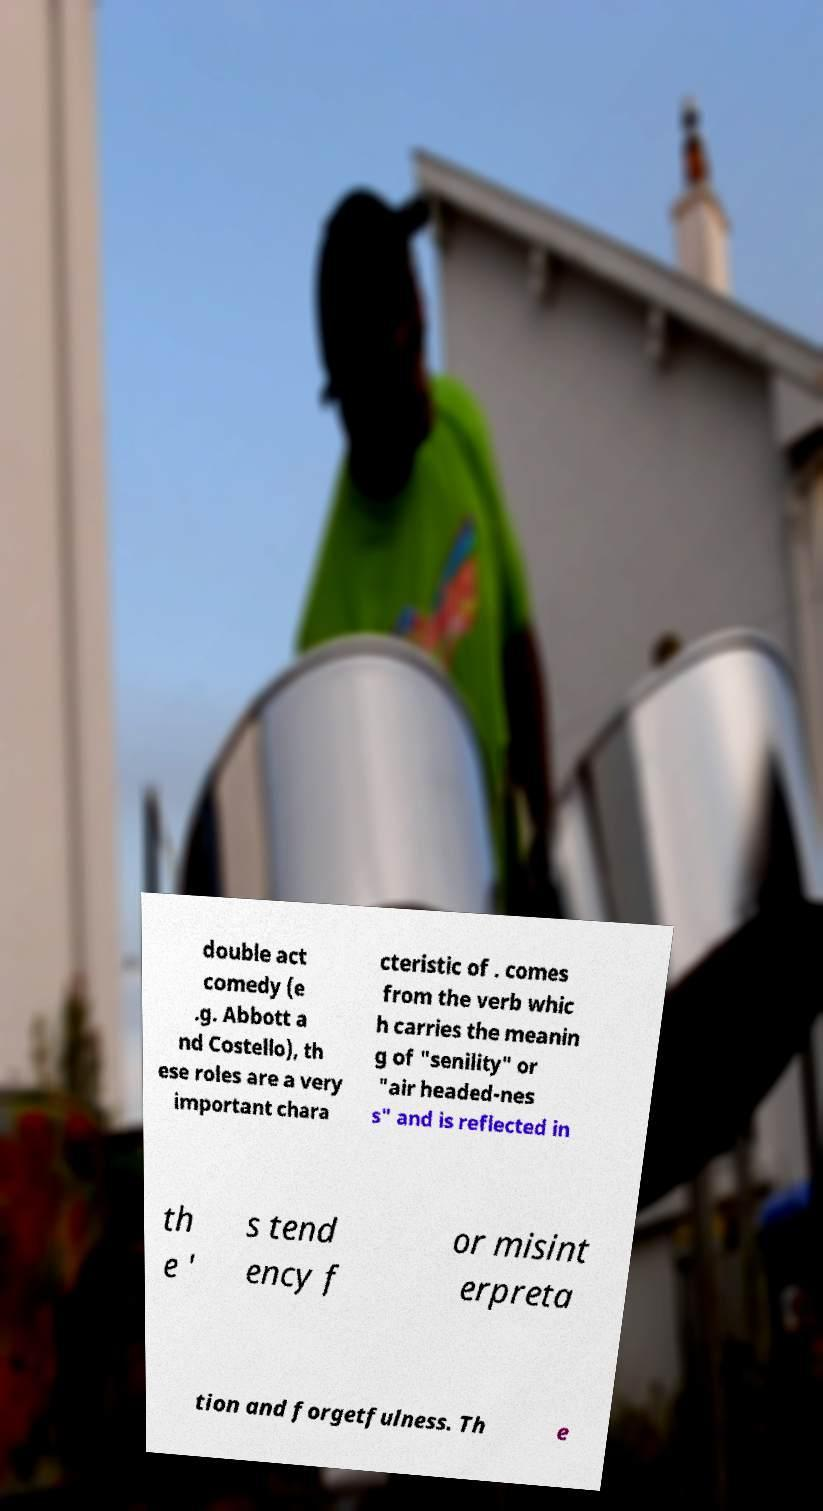Please read and relay the text visible in this image. What does it say? double act comedy (e .g. Abbott a nd Costello), th ese roles are a very important chara cteristic of . comes from the verb whic h carries the meanin g of "senility" or "air headed-nes s" and is reflected in th e ' s tend ency f or misint erpreta tion and forgetfulness. Th e 